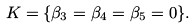<formula> <loc_0><loc_0><loc_500><loc_500>K = \{ \beta _ { 3 } = \beta _ { 4 } = \beta _ { 5 } = 0 \} .</formula> 